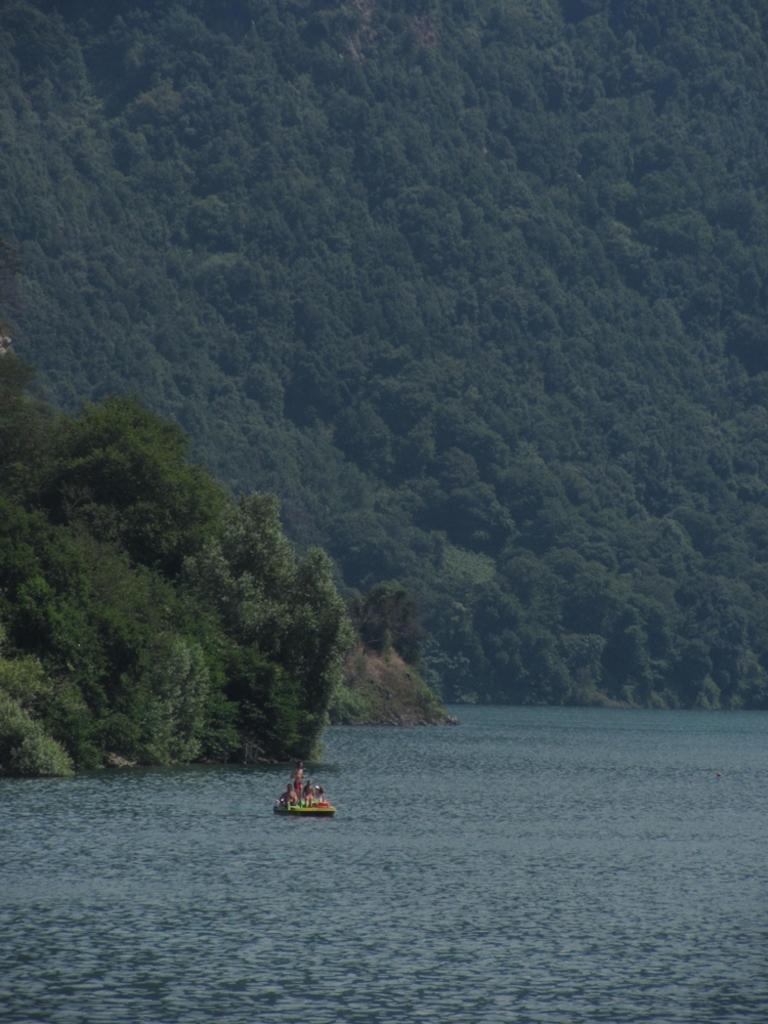Please provide a concise description of this image. In this image there are some persons boating on the surface of the river. In the background we can see a mountain with full of trees. 